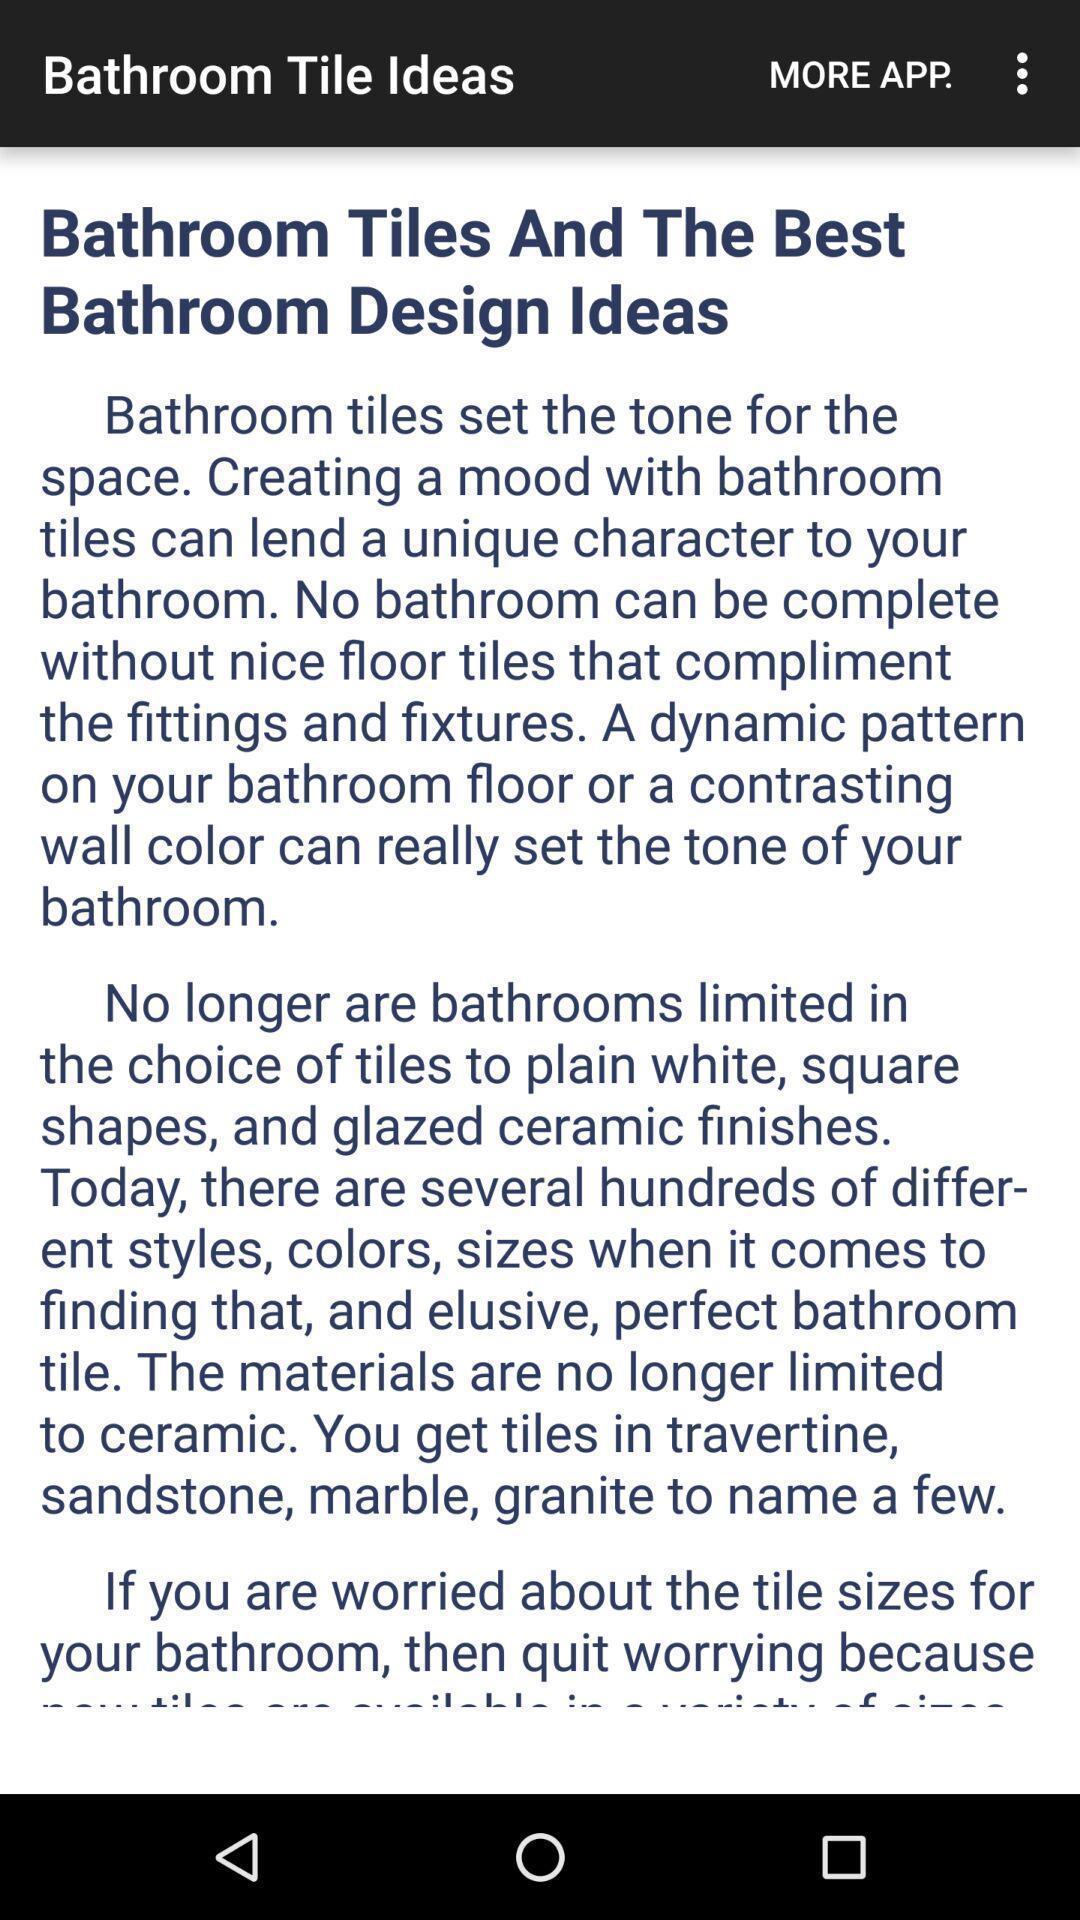Describe the content in this image. Page displaying the information. 